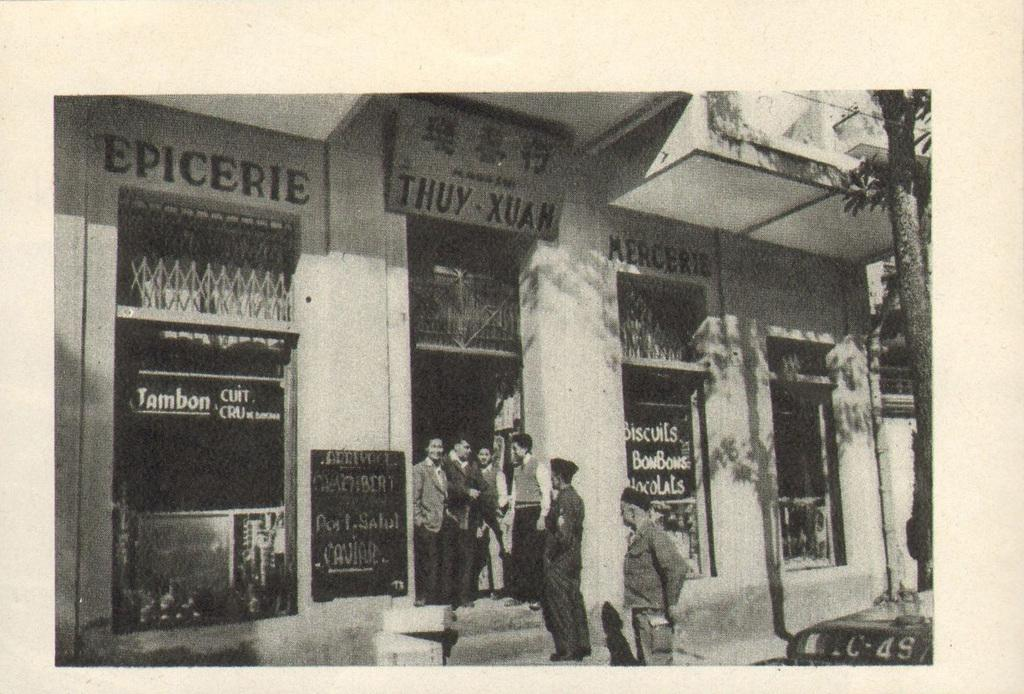What is the color scheme of the image? The image is black and white. Who or what can be seen in the image? There are people in the image. What type of natural element is present in the image? There is a tree in the image. What man-made structures can be seen in the image? There are boards, grilles, and walls in the image. What is written on the boards? Something is written on the boards, but we cannot determine the exact content from the image. How many clocks are visible in the image? There are no clocks present in the image. What type of pen is being used to write on the boards? There is no pen visible in the image, and we cannot determine the writing instrument used from the image. 